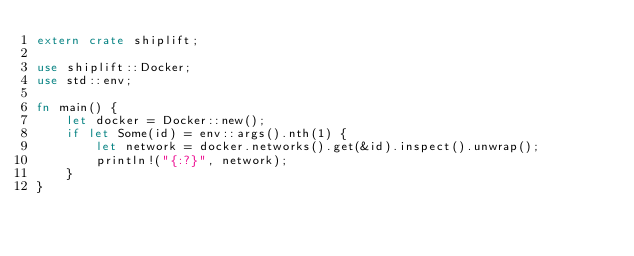Convert code to text. <code><loc_0><loc_0><loc_500><loc_500><_Rust_>extern crate shiplift;

use shiplift::Docker;
use std::env;

fn main() {
    let docker = Docker::new();
    if let Some(id) = env::args().nth(1) {
        let network = docker.networks().get(&id).inspect().unwrap();
        println!("{:?}", network);
    }
}
</code> 